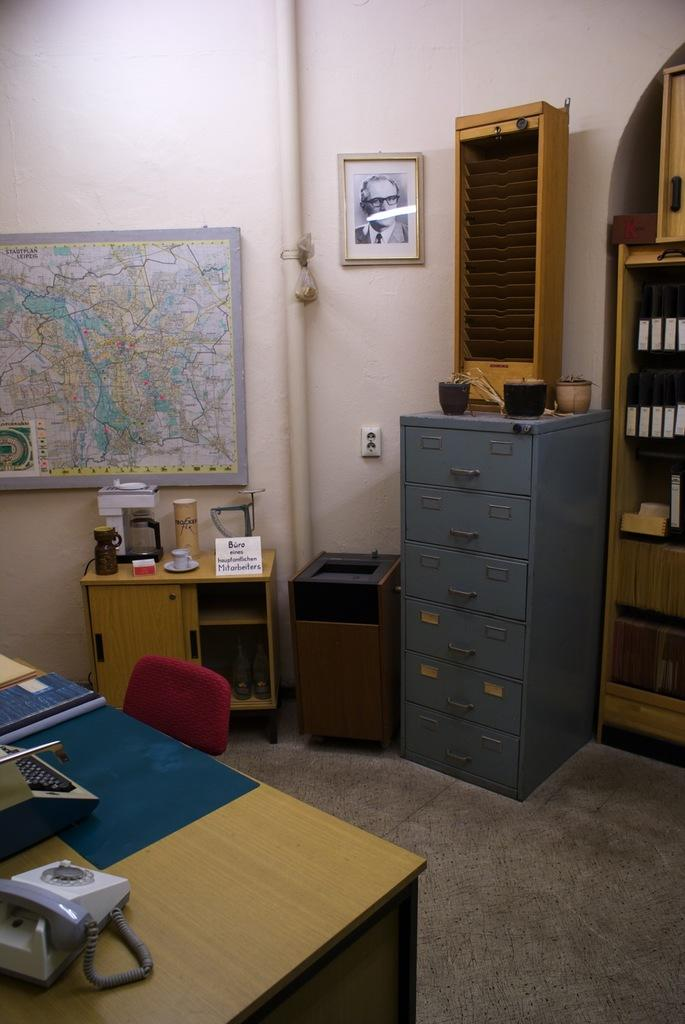What type of furniture is present in the room? There is a table and a chair in the room. What can be seen on the wall in the room? There is a map on the wall. Are there any decorative items in the room? Yes, there is a photo frame in the room. What type of storage furniture is in the room? There is a set of drawers in the room. Where is the clover growing in the room? There is no clover present in the room. What type of musical instrument is in the room? There is no musical instrument, such as a drum, present in the room. 